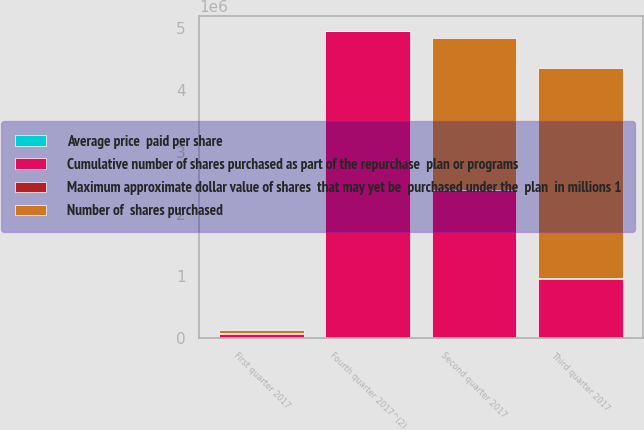Convert chart. <chart><loc_0><loc_0><loc_500><loc_500><stacked_bar_chart><ecel><fcel>First quarter 2017<fcel>Second quarter 2017<fcel>Third quarter 2017<fcel>Fourth quarter 2017^(2)<nl><fcel>Cumulative number of shares purchased as part of the repurchase  plan or programs<fcel>63812<fcel>2.38432e+06<fcel>951866<fcel>4.94241e+06<nl><fcel>Average price  paid per share<fcel>103.84<fcel>103.4<fcel>101.67<fcel>100.76<nl><fcel>Number of  shares purchased<fcel>63812<fcel>2.44814e+06<fcel>3.4e+06<fcel>1493.4<nl><fcel>Maximum approximate dollar value of shares  that may yet be  purchased under the  plan  in millions 1<fcel>1493.4<fcel>1246.8<fcel>1150<fcel>652<nl></chart> 